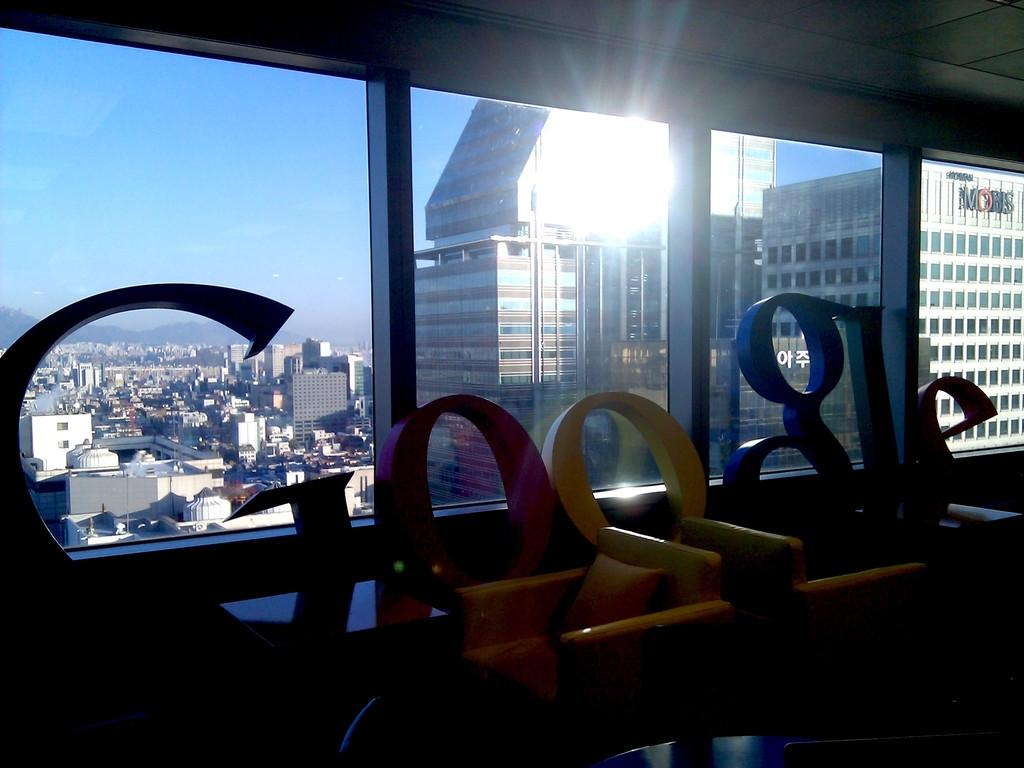What is the main structure visible in the image? There is a building in the image. What is located in front of the building? There is text along with sofas in the front of the image. What can be seen in the background of the image? There are windows in the background of the image. What is visible through the windows? Multiple buildings and the sky are visible through the windows. What type of friction can be observed between the canvas and the foot in the image? There is no canvas or foot present in the image, so no friction can be observed. 